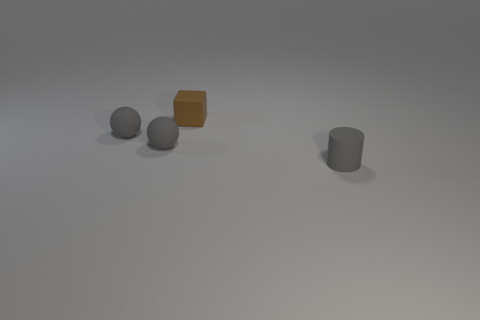How does the lighting in the image affect the appearance of these objects? The lighting in the image seems to come from above, casting subtle shadows beneath each object. The highlights and shadows contribute to the three-dimensional appearance of the objects, enhancing their shapes and providing a sense of depth in the image. 